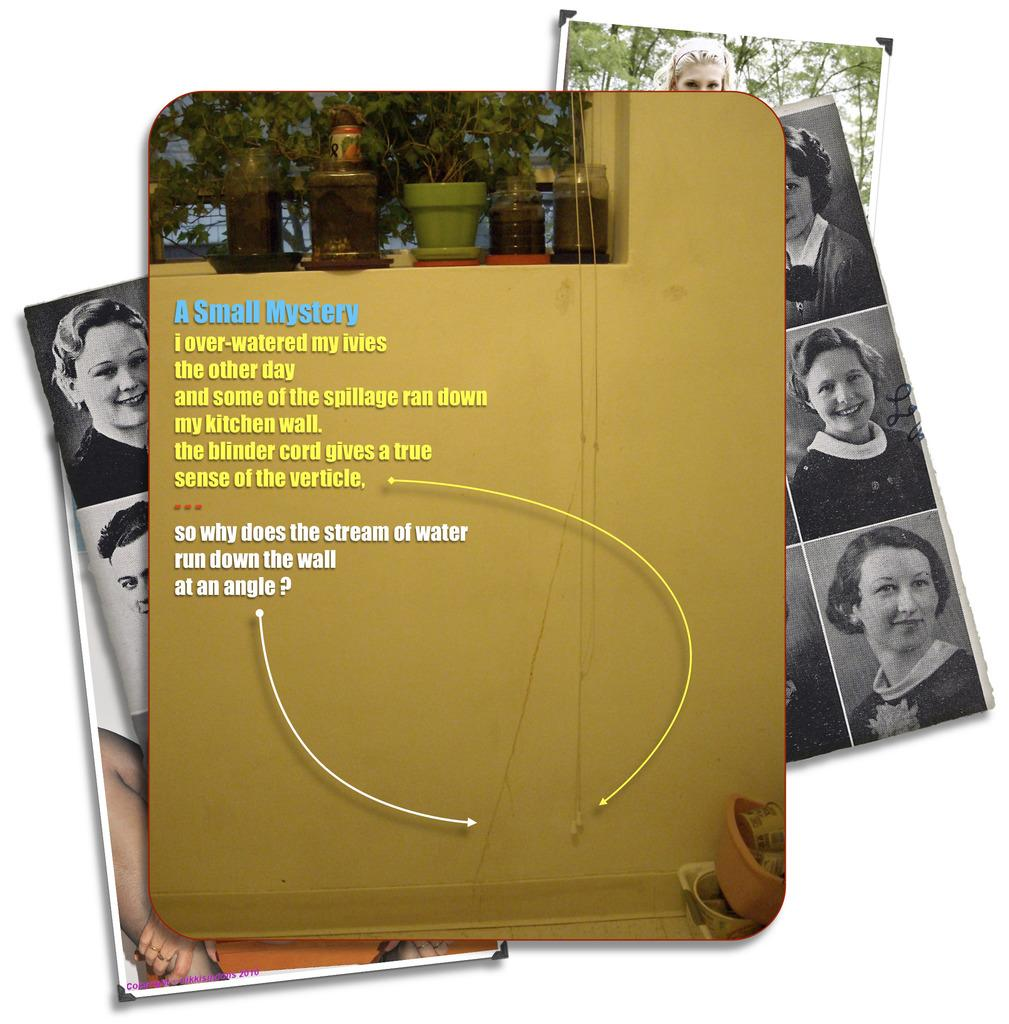What type of objects are featured on the posters in the image? The posters have images of a person. Are there any words or letters on the posters? Yes, the posters have text on them. What else can be seen in the image besides the posters? There are potted plants in the image. What type of thread is being used to hold the cup in the image? There is no cup present in the image, and therefore no thread is being used to hold it. Can you describe the uncle's appearance in the image? There is no uncle present in the image, so it is not possible to describe his appearance. 